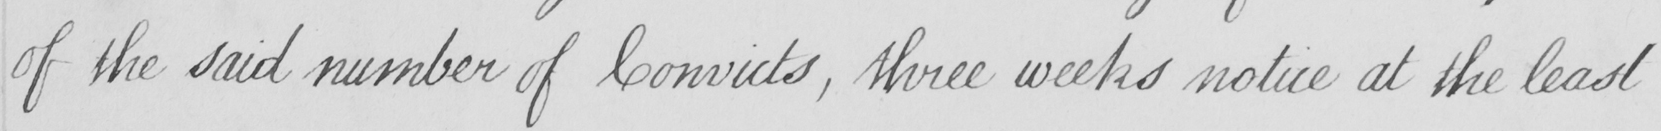What text is written in this handwritten line? of the said number of Convicts , three weeks notice at the least 